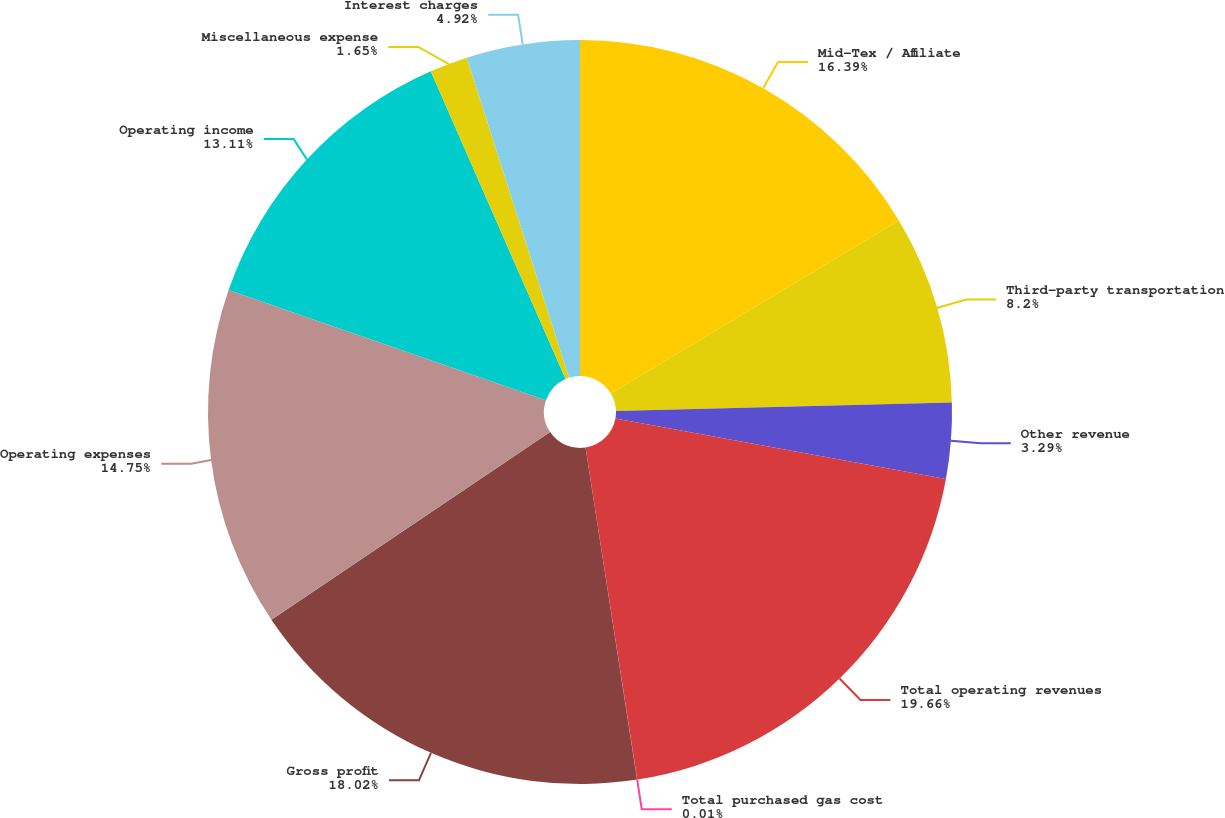Convert chart to OTSL. <chart><loc_0><loc_0><loc_500><loc_500><pie_chart><fcel>Mid-Tex / Affiliate<fcel>Third-party transportation<fcel>Other revenue<fcel>Total operating revenues<fcel>Total purchased gas cost<fcel>Gross profit<fcel>Operating expenses<fcel>Operating income<fcel>Miscellaneous expense<fcel>Interest charges<nl><fcel>16.39%<fcel>8.2%<fcel>3.29%<fcel>19.66%<fcel>0.01%<fcel>18.02%<fcel>14.75%<fcel>13.11%<fcel>1.65%<fcel>4.92%<nl></chart> 